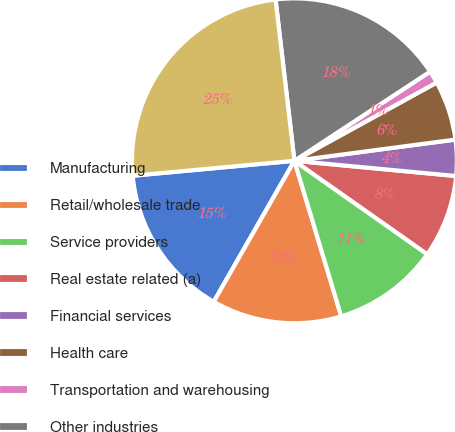Convert chart. <chart><loc_0><loc_0><loc_500><loc_500><pie_chart><fcel>Manufacturing<fcel>Retail/wholesale trade<fcel>Service providers<fcel>Real estate related (a)<fcel>Financial services<fcel>Health care<fcel>Transportation and warehousing<fcel>Other industries<fcel>Total commercial loans<nl><fcel>15.26%<fcel>12.93%<fcel>10.59%<fcel>8.26%<fcel>3.58%<fcel>5.92%<fcel>1.25%<fcel>17.6%<fcel>24.61%<nl></chart> 